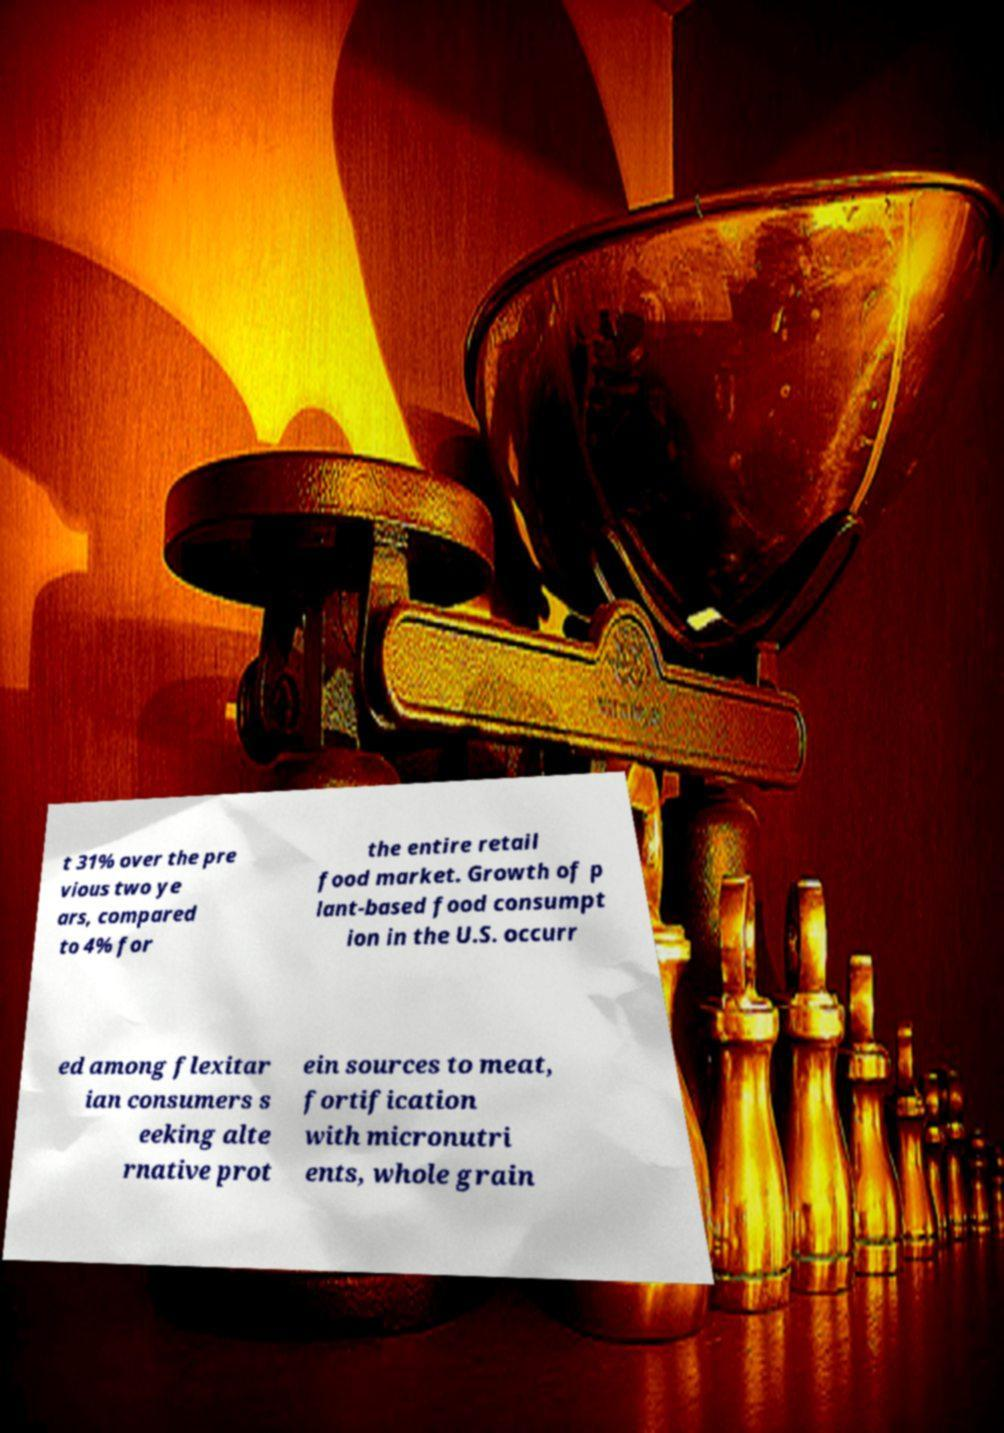Can you accurately transcribe the text from the provided image for me? t 31% over the pre vious two ye ars, compared to 4% for the entire retail food market. Growth of p lant-based food consumpt ion in the U.S. occurr ed among flexitar ian consumers s eeking alte rnative prot ein sources to meat, fortification with micronutri ents, whole grain 